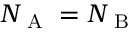<formula> <loc_0><loc_0><loc_500><loc_500>N _ { A } = N _ { B }</formula> 